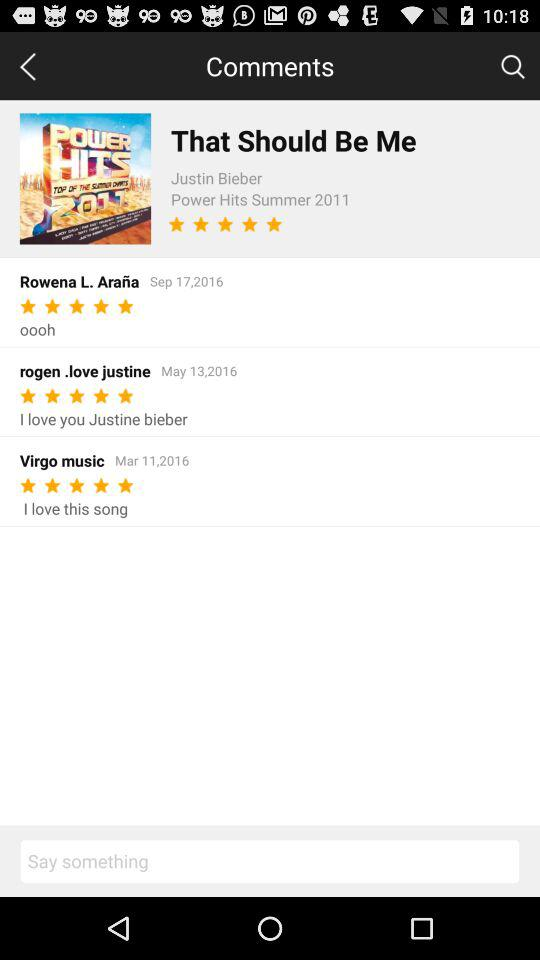When was the comment by "Virgo music" posted? The comment by "Virgo music" was posted on March 11, 2016. 